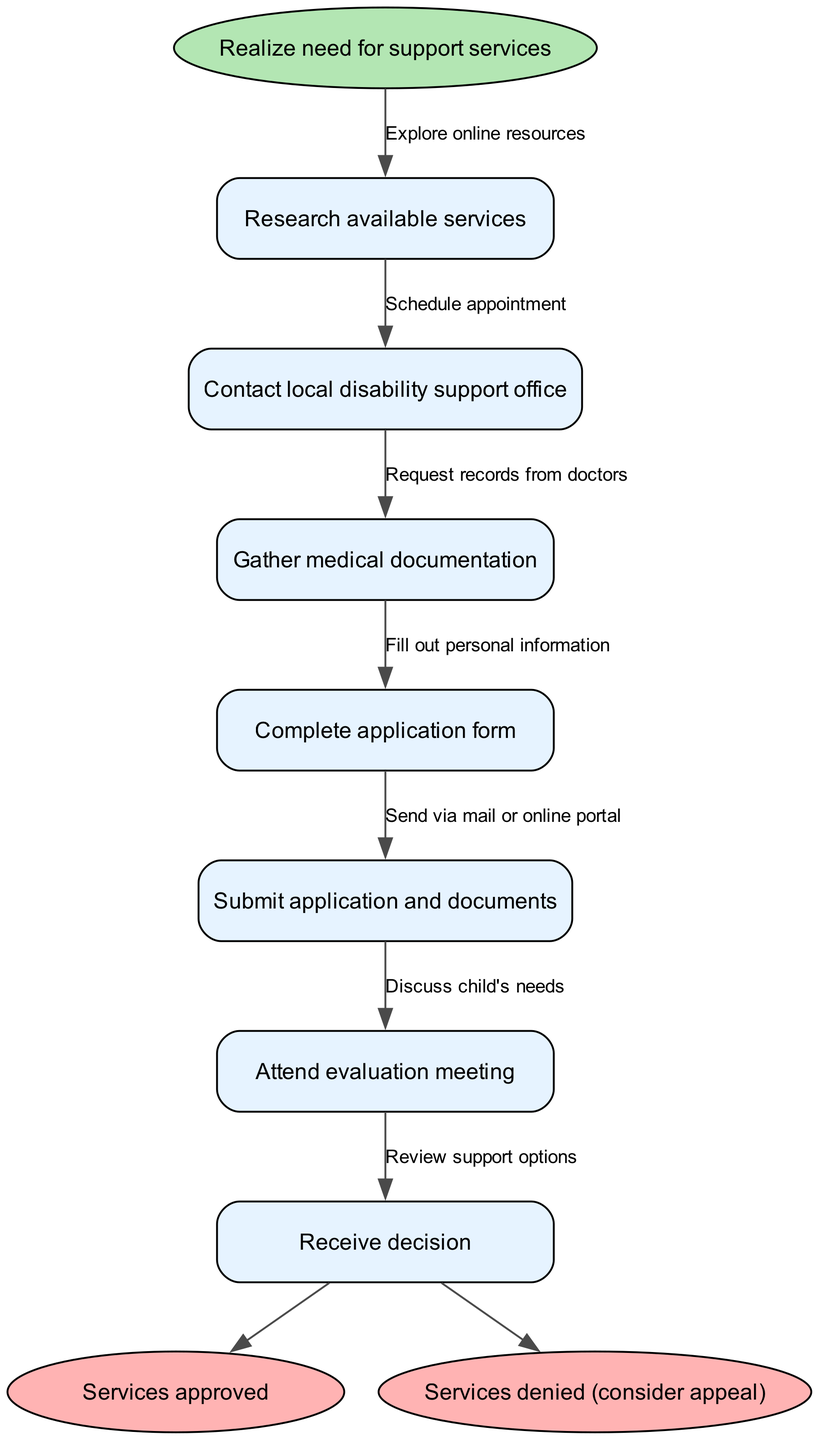What is the first step in the process? The first step is indicated as the start node in the diagram, which states "Realize need for support services."
Answer: Realize need for support services How many nodes are there in total? Counting the start node, process nodes, and end nodes provides the total. There is 1 start node, 7 process nodes, and 2 end nodes, resulting in 1 + 7 + 2 = 10 nodes.
Answer: 10 What is the final outcome if services are approved? The final outcome after following the process is indicated by one of the end nodes, which states "Services approved."
Answer: Services approved Which node comes after completing the application form? After "Complete application form," the next step in the flow is "Submit application and documents." This is determined by checking the directed edges connecting the nodes.
Answer: Submit application and documents How do you go from attending the evaluation meeting to receiving a decision? The flow from "Attend evaluation meeting" leads to the next step where the outcome is "Receive decision." This is deduced by tracing the edge connection from the evaluation node to the decision node.
Answer: Receive decision What should you do after gathering medical documentation? The process requires you to "Complete application form" after gathering medical documentation, as shown by the directed flow connecting those two processes.
Answer: Complete application form If your application is denied, what option do you have? One option provided at the end of the flow if services are denied is to "consider appeal," as indicated in the respective end node.
Answer: consider appeal Which node corresponds to discussing your child's needs? The discussion of the child's needs correlates with the node "Discuss child's needs," which is linked to the "Attend evaluation meeting" node in the flow.
Answer: Discuss child's needs What edge is labeled between the "Research available services" and "Contact local disability support office" nodes? The edge label connecting these two nodes is "Explore online resources," as indicated in the labeled edge between the respective process nodes.
Answer: Explore online resources 